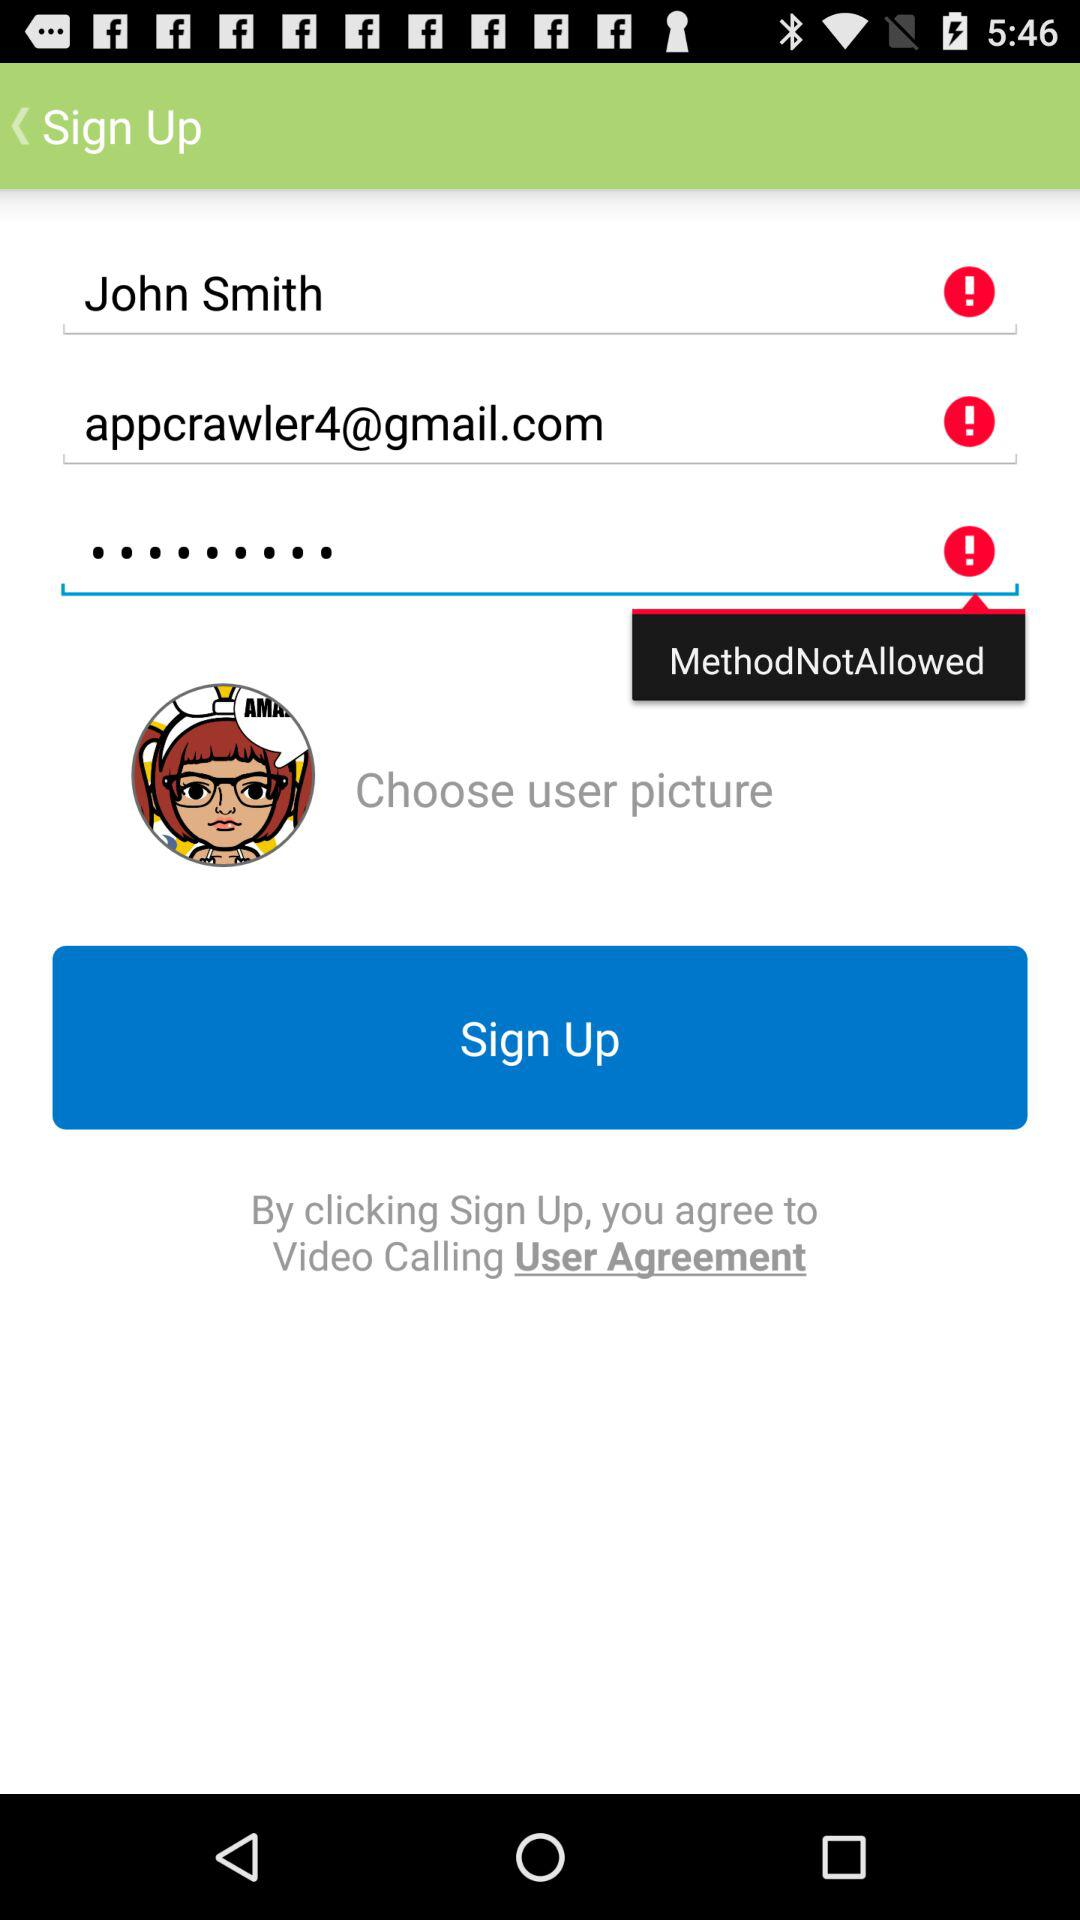What is the user name? The user name is John Smith. 